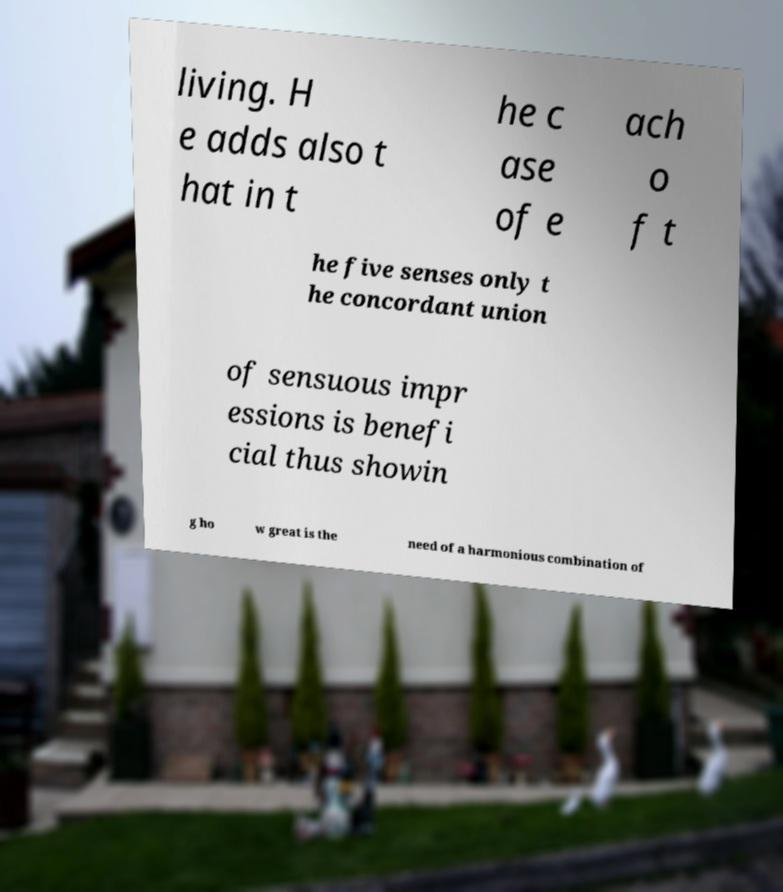Please identify and transcribe the text found in this image. living. H e adds also t hat in t he c ase of e ach o f t he five senses only t he concordant union of sensuous impr essions is benefi cial thus showin g ho w great is the need of a harmonious combination of 